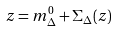<formula> <loc_0><loc_0><loc_500><loc_500>z = m _ { \Delta } ^ { 0 } + \Sigma _ { \Delta } ( z )</formula> 